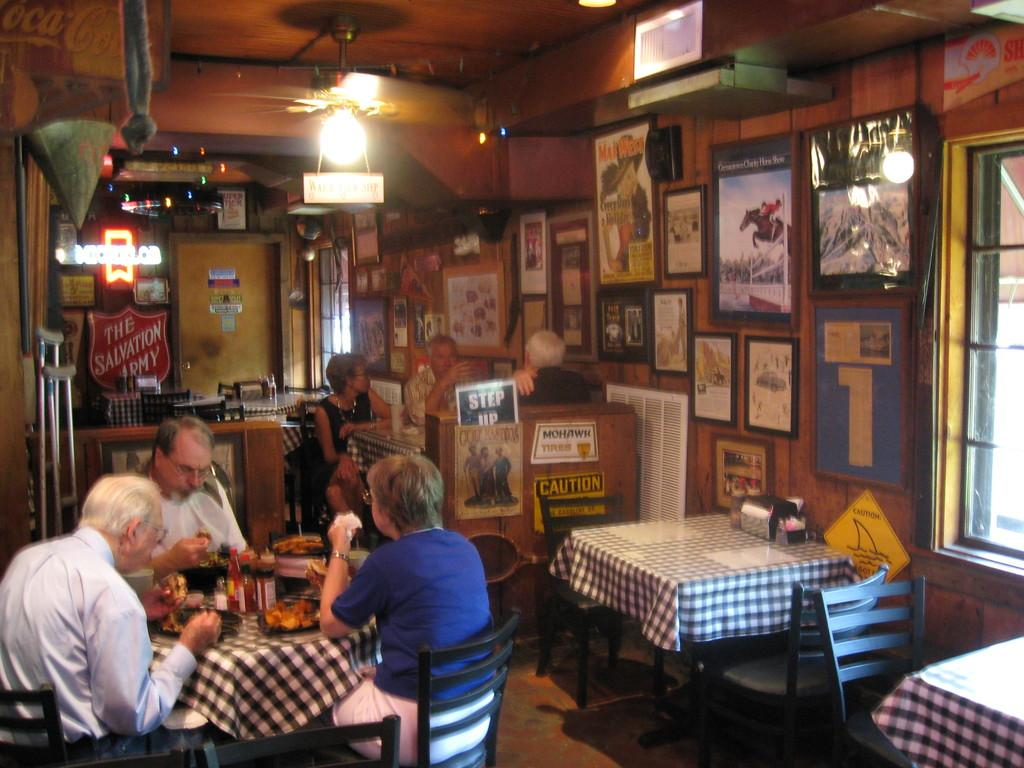What is happening in the image? There are people sitting around a table in the image. What can be seen on the wall in the background? There are photo frames on the wall in the background of the image. What is visible on the ceiling in the background? There are lights on the ceiling in the background of the image. What type of gun is being used by the people sitting around the table in the image? There is no gun present in the image; people are sitting around a table. What color are the stockings worn by the people in the image? There is no mention of stockings or any clothing details in the image. 